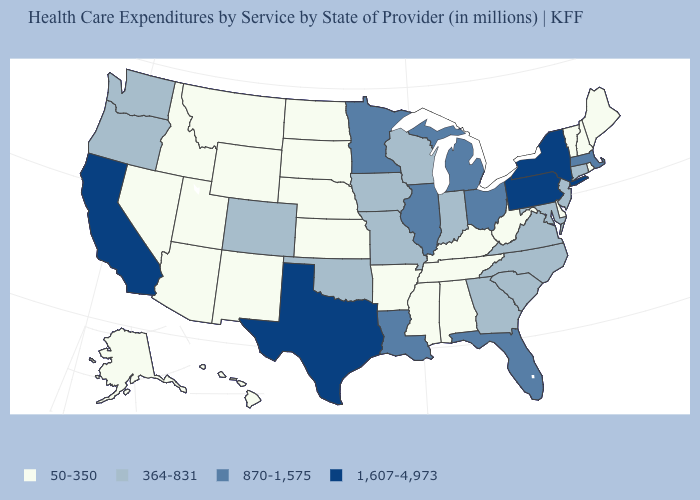Does Maine have the lowest value in the Northeast?
Write a very short answer. Yes. Which states hav the highest value in the MidWest?
Short answer required. Illinois, Michigan, Minnesota, Ohio. How many symbols are there in the legend?
Keep it brief. 4. What is the value of Alaska?
Give a very brief answer. 50-350. What is the value of Oklahoma?
Concise answer only. 364-831. Name the states that have a value in the range 1,607-4,973?
Write a very short answer. California, New York, Pennsylvania, Texas. What is the value of Illinois?
Quick response, please. 870-1,575. What is the value of Utah?
Answer briefly. 50-350. What is the value of Hawaii?
Be succinct. 50-350. What is the lowest value in the USA?
Write a very short answer. 50-350. Does Missouri have a lower value than Alaska?
Concise answer only. No. What is the value of Delaware?
Answer briefly. 50-350. What is the lowest value in states that border Michigan?
Keep it brief. 364-831. Does Washington have the lowest value in the West?
Short answer required. No. What is the value of Nevada?
Write a very short answer. 50-350. 